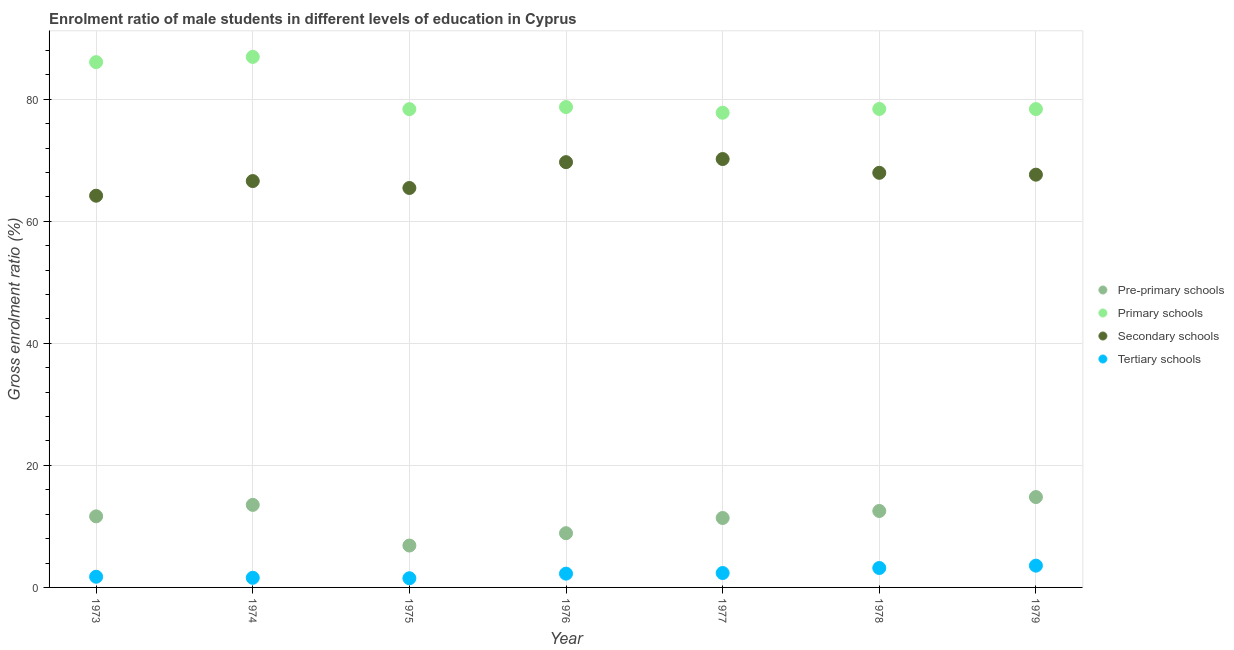Is the number of dotlines equal to the number of legend labels?
Your response must be concise. Yes. What is the gross enrolment ratio(female) in pre-primary schools in 1978?
Offer a very short reply. 12.53. Across all years, what is the maximum gross enrolment ratio(female) in primary schools?
Give a very brief answer. 86.93. Across all years, what is the minimum gross enrolment ratio(female) in primary schools?
Your answer should be very brief. 77.78. In which year was the gross enrolment ratio(female) in pre-primary schools maximum?
Ensure brevity in your answer.  1979. In which year was the gross enrolment ratio(female) in primary schools minimum?
Provide a succinct answer. 1977. What is the total gross enrolment ratio(female) in primary schools in the graph?
Provide a short and direct response. 564.64. What is the difference between the gross enrolment ratio(female) in primary schools in 1976 and that in 1979?
Your answer should be compact. 0.33. What is the difference between the gross enrolment ratio(female) in secondary schools in 1978 and the gross enrolment ratio(female) in pre-primary schools in 1976?
Keep it short and to the point. 59.05. What is the average gross enrolment ratio(female) in pre-primary schools per year?
Offer a terse response. 11.37. In the year 1979, what is the difference between the gross enrolment ratio(female) in tertiary schools and gross enrolment ratio(female) in primary schools?
Your response must be concise. -74.81. In how many years, is the gross enrolment ratio(female) in secondary schools greater than 32 %?
Your answer should be very brief. 7. What is the ratio of the gross enrolment ratio(female) in primary schools in 1976 to that in 1978?
Offer a very short reply. 1. What is the difference between the highest and the second highest gross enrolment ratio(female) in pre-primary schools?
Your answer should be compact. 1.28. What is the difference between the highest and the lowest gross enrolment ratio(female) in tertiary schools?
Your answer should be compact. 2.07. Is it the case that in every year, the sum of the gross enrolment ratio(female) in pre-primary schools and gross enrolment ratio(female) in primary schools is greater than the gross enrolment ratio(female) in secondary schools?
Keep it short and to the point. Yes. How many dotlines are there?
Give a very brief answer. 4. Are the values on the major ticks of Y-axis written in scientific E-notation?
Provide a short and direct response. No. Does the graph contain any zero values?
Your response must be concise. No. How are the legend labels stacked?
Keep it short and to the point. Vertical. What is the title of the graph?
Your response must be concise. Enrolment ratio of male students in different levels of education in Cyprus. Does "Belgium" appear as one of the legend labels in the graph?
Provide a short and direct response. No. What is the Gross enrolment ratio (%) of Pre-primary schools in 1973?
Your response must be concise. 11.64. What is the Gross enrolment ratio (%) of Primary schools in 1973?
Ensure brevity in your answer.  86.07. What is the Gross enrolment ratio (%) in Secondary schools in 1973?
Ensure brevity in your answer.  64.19. What is the Gross enrolment ratio (%) in Tertiary schools in 1973?
Your response must be concise. 1.75. What is the Gross enrolment ratio (%) of Pre-primary schools in 1974?
Provide a short and direct response. 13.52. What is the Gross enrolment ratio (%) in Primary schools in 1974?
Your answer should be very brief. 86.93. What is the Gross enrolment ratio (%) in Secondary schools in 1974?
Your answer should be very brief. 66.58. What is the Gross enrolment ratio (%) in Tertiary schools in 1974?
Give a very brief answer. 1.58. What is the Gross enrolment ratio (%) of Pre-primary schools in 1975?
Your answer should be compact. 6.86. What is the Gross enrolment ratio (%) of Primary schools in 1975?
Your answer should be compact. 78.37. What is the Gross enrolment ratio (%) in Secondary schools in 1975?
Ensure brevity in your answer.  65.45. What is the Gross enrolment ratio (%) of Tertiary schools in 1975?
Make the answer very short. 1.5. What is the Gross enrolment ratio (%) of Pre-primary schools in 1976?
Offer a very short reply. 8.88. What is the Gross enrolment ratio (%) of Primary schools in 1976?
Offer a very short reply. 78.71. What is the Gross enrolment ratio (%) in Secondary schools in 1976?
Provide a short and direct response. 69.68. What is the Gross enrolment ratio (%) in Tertiary schools in 1976?
Offer a very short reply. 2.26. What is the Gross enrolment ratio (%) of Pre-primary schools in 1977?
Keep it short and to the point. 11.38. What is the Gross enrolment ratio (%) of Primary schools in 1977?
Offer a very short reply. 77.78. What is the Gross enrolment ratio (%) in Secondary schools in 1977?
Ensure brevity in your answer.  70.19. What is the Gross enrolment ratio (%) of Tertiary schools in 1977?
Offer a terse response. 2.36. What is the Gross enrolment ratio (%) in Pre-primary schools in 1978?
Your response must be concise. 12.53. What is the Gross enrolment ratio (%) of Primary schools in 1978?
Keep it short and to the point. 78.4. What is the Gross enrolment ratio (%) in Secondary schools in 1978?
Offer a terse response. 67.94. What is the Gross enrolment ratio (%) in Tertiary schools in 1978?
Ensure brevity in your answer.  3.18. What is the Gross enrolment ratio (%) of Pre-primary schools in 1979?
Keep it short and to the point. 14.81. What is the Gross enrolment ratio (%) of Primary schools in 1979?
Provide a succinct answer. 78.38. What is the Gross enrolment ratio (%) of Secondary schools in 1979?
Your answer should be compact. 67.63. What is the Gross enrolment ratio (%) of Tertiary schools in 1979?
Provide a succinct answer. 3.57. Across all years, what is the maximum Gross enrolment ratio (%) in Pre-primary schools?
Provide a short and direct response. 14.81. Across all years, what is the maximum Gross enrolment ratio (%) of Primary schools?
Make the answer very short. 86.93. Across all years, what is the maximum Gross enrolment ratio (%) of Secondary schools?
Offer a very short reply. 70.19. Across all years, what is the maximum Gross enrolment ratio (%) in Tertiary schools?
Provide a succinct answer. 3.57. Across all years, what is the minimum Gross enrolment ratio (%) of Pre-primary schools?
Offer a very short reply. 6.86. Across all years, what is the minimum Gross enrolment ratio (%) in Primary schools?
Offer a terse response. 77.78. Across all years, what is the minimum Gross enrolment ratio (%) in Secondary schools?
Provide a short and direct response. 64.19. Across all years, what is the minimum Gross enrolment ratio (%) of Tertiary schools?
Give a very brief answer. 1.5. What is the total Gross enrolment ratio (%) of Pre-primary schools in the graph?
Offer a very short reply. 79.62. What is the total Gross enrolment ratio (%) of Primary schools in the graph?
Make the answer very short. 564.64. What is the total Gross enrolment ratio (%) in Secondary schools in the graph?
Provide a succinct answer. 471.66. What is the total Gross enrolment ratio (%) of Tertiary schools in the graph?
Keep it short and to the point. 16.2. What is the difference between the Gross enrolment ratio (%) of Pre-primary schools in 1973 and that in 1974?
Keep it short and to the point. -1.88. What is the difference between the Gross enrolment ratio (%) of Primary schools in 1973 and that in 1974?
Offer a terse response. -0.86. What is the difference between the Gross enrolment ratio (%) of Secondary schools in 1973 and that in 1974?
Offer a terse response. -2.4. What is the difference between the Gross enrolment ratio (%) of Tertiary schools in 1973 and that in 1974?
Make the answer very short. 0.17. What is the difference between the Gross enrolment ratio (%) of Pre-primary schools in 1973 and that in 1975?
Ensure brevity in your answer.  4.78. What is the difference between the Gross enrolment ratio (%) of Primary schools in 1973 and that in 1975?
Your response must be concise. 7.7. What is the difference between the Gross enrolment ratio (%) of Secondary schools in 1973 and that in 1975?
Ensure brevity in your answer.  -1.27. What is the difference between the Gross enrolment ratio (%) of Tertiary schools in 1973 and that in 1975?
Keep it short and to the point. 0.25. What is the difference between the Gross enrolment ratio (%) in Pre-primary schools in 1973 and that in 1976?
Offer a terse response. 2.76. What is the difference between the Gross enrolment ratio (%) of Primary schools in 1973 and that in 1976?
Provide a short and direct response. 7.36. What is the difference between the Gross enrolment ratio (%) in Secondary schools in 1973 and that in 1976?
Your answer should be compact. -5.5. What is the difference between the Gross enrolment ratio (%) in Tertiary schools in 1973 and that in 1976?
Ensure brevity in your answer.  -0.51. What is the difference between the Gross enrolment ratio (%) in Pre-primary schools in 1973 and that in 1977?
Offer a very short reply. 0.27. What is the difference between the Gross enrolment ratio (%) in Primary schools in 1973 and that in 1977?
Offer a terse response. 8.29. What is the difference between the Gross enrolment ratio (%) in Secondary schools in 1973 and that in 1977?
Make the answer very short. -6.01. What is the difference between the Gross enrolment ratio (%) in Tertiary schools in 1973 and that in 1977?
Your response must be concise. -0.61. What is the difference between the Gross enrolment ratio (%) in Pre-primary schools in 1973 and that in 1978?
Make the answer very short. -0.88. What is the difference between the Gross enrolment ratio (%) in Primary schools in 1973 and that in 1978?
Your answer should be very brief. 7.67. What is the difference between the Gross enrolment ratio (%) of Secondary schools in 1973 and that in 1978?
Provide a succinct answer. -3.75. What is the difference between the Gross enrolment ratio (%) in Tertiary schools in 1973 and that in 1978?
Your answer should be compact. -1.43. What is the difference between the Gross enrolment ratio (%) in Pre-primary schools in 1973 and that in 1979?
Make the answer very short. -3.16. What is the difference between the Gross enrolment ratio (%) in Primary schools in 1973 and that in 1979?
Ensure brevity in your answer.  7.69. What is the difference between the Gross enrolment ratio (%) in Secondary schools in 1973 and that in 1979?
Provide a short and direct response. -3.45. What is the difference between the Gross enrolment ratio (%) of Tertiary schools in 1973 and that in 1979?
Offer a terse response. -1.82. What is the difference between the Gross enrolment ratio (%) of Pre-primary schools in 1974 and that in 1975?
Make the answer very short. 6.66. What is the difference between the Gross enrolment ratio (%) of Primary schools in 1974 and that in 1975?
Provide a short and direct response. 8.56. What is the difference between the Gross enrolment ratio (%) in Secondary schools in 1974 and that in 1975?
Provide a succinct answer. 1.13. What is the difference between the Gross enrolment ratio (%) in Tertiary schools in 1974 and that in 1975?
Make the answer very short. 0.07. What is the difference between the Gross enrolment ratio (%) in Pre-primary schools in 1974 and that in 1976?
Make the answer very short. 4.64. What is the difference between the Gross enrolment ratio (%) of Primary schools in 1974 and that in 1976?
Provide a succinct answer. 8.22. What is the difference between the Gross enrolment ratio (%) in Secondary schools in 1974 and that in 1976?
Ensure brevity in your answer.  -3.1. What is the difference between the Gross enrolment ratio (%) of Tertiary schools in 1974 and that in 1976?
Provide a succinct answer. -0.68. What is the difference between the Gross enrolment ratio (%) in Pre-primary schools in 1974 and that in 1977?
Offer a terse response. 2.15. What is the difference between the Gross enrolment ratio (%) in Primary schools in 1974 and that in 1977?
Make the answer very short. 9.15. What is the difference between the Gross enrolment ratio (%) of Secondary schools in 1974 and that in 1977?
Offer a terse response. -3.61. What is the difference between the Gross enrolment ratio (%) in Tertiary schools in 1974 and that in 1977?
Keep it short and to the point. -0.78. What is the difference between the Gross enrolment ratio (%) of Pre-primary schools in 1974 and that in 1978?
Ensure brevity in your answer.  1. What is the difference between the Gross enrolment ratio (%) of Primary schools in 1974 and that in 1978?
Make the answer very short. 8.53. What is the difference between the Gross enrolment ratio (%) in Secondary schools in 1974 and that in 1978?
Your answer should be very brief. -1.35. What is the difference between the Gross enrolment ratio (%) of Tertiary schools in 1974 and that in 1978?
Offer a terse response. -1.6. What is the difference between the Gross enrolment ratio (%) of Pre-primary schools in 1974 and that in 1979?
Offer a terse response. -1.28. What is the difference between the Gross enrolment ratio (%) of Primary schools in 1974 and that in 1979?
Make the answer very short. 8.55. What is the difference between the Gross enrolment ratio (%) in Secondary schools in 1974 and that in 1979?
Keep it short and to the point. -1.05. What is the difference between the Gross enrolment ratio (%) of Tertiary schools in 1974 and that in 1979?
Keep it short and to the point. -1.99. What is the difference between the Gross enrolment ratio (%) of Pre-primary schools in 1975 and that in 1976?
Your answer should be compact. -2.02. What is the difference between the Gross enrolment ratio (%) in Primary schools in 1975 and that in 1976?
Offer a very short reply. -0.34. What is the difference between the Gross enrolment ratio (%) of Secondary schools in 1975 and that in 1976?
Offer a terse response. -4.23. What is the difference between the Gross enrolment ratio (%) in Tertiary schools in 1975 and that in 1976?
Offer a terse response. -0.75. What is the difference between the Gross enrolment ratio (%) in Pre-primary schools in 1975 and that in 1977?
Your answer should be compact. -4.51. What is the difference between the Gross enrolment ratio (%) in Primary schools in 1975 and that in 1977?
Your answer should be compact. 0.59. What is the difference between the Gross enrolment ratio (%) in Secondary schools in 1975 and that in 1977?
Provide a short and direct response. -4.74. What is the difference between the Gross enrolment ratio (%) in Tertiary schools in 1975 and that in 1977?
Ensure brevity in your answer.  -0.86. What is the difference between the Gross enrolment ratio (%) in Pre-primary schools in 1975 and that in 1978?
Offer a terse response. -5.66. What is the difference between the Gross enrolment ratio (%) of Primary schools in 1975 and that in 1978?
Give a very brief answer. -0.03. What is the difference between the Gross enrolment ratio (%) in Secondary schools in 1975 and that in 1978?
Ensure brevity in your answer.  -2.48. What is the difference between the Gross enrolment ratio (%) in Tertiary schools in 1975 and that in 1978?
Your answer should be compact. -1.68. What is the difference between the Gross enrolment ratio (%) of Pre-primary schools in 1975 and that in 1979?
Offer a very short reply. -7.94. What is the difference between the Gross enrolment ratio (%) of Primary schools in 1975 and that in 1979?
Provide a succinct answer. -0.01. What is the difference between the Gross enrolment ratio (%) in Secondary schools in 1975 and that in 1979?
Your response must be concise. -2.18. What is the difference between the Gross enrolment ratio (%) in Tertiary schools in 1975 and that in 1979?
Your answer should be compact. -2.07. What is the difference between the Gross enrolment ratio (%) of Pre-primary schools in 1976 and that in 1977?
Make the answer very short. -2.49. What is the difference between the Gross enrolment ratio (%) in Primary schools in 1976 and that in 1977?
Keep it short and to the point. 0.93. What is the difference between the Gross enrolment ratio (%) in Secondary schools in 1976 and that in 1977?
Your answer should be compact. -0.51. What is the difference between the Gross enrolment ratio (%) in Tertiary schools in 1976 and that in 1977?
Provide a succinct answer. -0.1. What is the difference between the Gross enrolment ratio (%) in Pre-primary schools in 1976 and that in 1978?
Make the answer very short. -3.64. What is the difference between the Gross enrolment ratio (%) in Primary schools in 1976 and that in 1978?
Provide a short and direct response. 0.31. What is the difference between the Gross enrolment ratio (%) of Secondary schools in 1976 and that in 1978?
Provide a succinct answer. 1.75. What is the difference between the Gross enrolment ratio (%) of Tertiary schools in 1976 and that in 1978?
Provide a short and direct response. -0.92. What is the difference between the Gross enrolment ratio (%) in Pre-primary schools in 1976 and that in 1979?
Give a very brief answer. -5.92. What is the difference between the Gross enrolment ratio (%) in Primary schools in 1976 and that in 1979?
Keep it short and to the point. 0.33. What is the difference between the Gross enrolment ratio (%) of Secondary schools in 1976 and that in 1979?
Offer a terse response. 2.05. What is the difference between the Gross enrolment ratio (%) of Tertiary schools in 1976 and that in 1979?
Provide a short and direct response. -1.31. What is the difference between the Gross enrolment ratio (%) of Pre-primary schools in 1977 and that in 1978?
Ensure brevity in your answer.  -1.15. What is the difference between the Gross enrolment ratio (%) of Primary schools in 1977 and that in 1978?
Ensure brevity in your answer.  -0.62. What is the difference between the Gross enrolment ratio (%) in Secondary schools in 1977 and that in 1978?
Keep it short and to the point. 2.26. What is the difference between the Gross enrolment ratio (%) of Tertiary schools in 1977 and that in 1978?
Offer a terse response. -0.82. What is the difference between the Gross enrolment ratio (%) of Pre-primary schools in 1977 and that in 1979?
Your answer should be compact. -3.43. What is the difference between the Gross enrolment ratio (%) in Primary schools in 1977 and that in 1979?
Provide a succinct answer. -0.6. What is the difference between the Gross enrolment ratio (%) in Secondary schools in 1977 and that in 1979?
Keep it short and to the point. 2.56. What is the difference between the Gross enrolment ratio (%) in Tertiary schools in 1977 and that in 1979?
Ensure brevity in your answer.  -1.21. What is the difference between the Gross enrolment ratio (%) of Pre-primary schools in 1978 and that in 1979?
Your answer should be very brief. -2.28. What is the difference between the Gross enrolment ratio (%) in Primary schools in 1978 and that in 1979?
Ensure brevity in your answer.  0.02. What is the difference between the Gross enrolment ratio (%) in Secondary schools in 1978 and that in 1979?
Give a very brief answer. 0.3. What is the difference between the Gross enrolment ratio (%) of Tertiary schools in 1978 and that in 1979?
Provide a succinct answer. -0.39. What is the difference between the Gross enrolment ratio (%) of Pre-primary schools in 1973 and the Gross enrolment ratio (%) of Primary schools in 1974?
Keep it short and to the point. -75.29. What is the difference between the Gross enrolment ratio (%) in Pre-primary schools in 1973 and the Gross enrolment ratio (%) in Secondary schools in 1974?
Give a very brief answer. -54.94. What is the difference between the Gross enrolment ratio (%) in Pre-primary schools in 1973 and the Gross enrolment ratio (%) in Tertiary schools in 1974?
Provide a short and direct response. 10.07. What is the difference between the Gross enrolment ratio (%) in Primary schools in 1973 and the Gross enrolment ratio (%) in Secondary schools in 1974?
Give a very brief answer. 19.49. What is the difference between the Gross enrolment ratio (%) in Primary schools in 1973 and the Gross enrolment ratio (%) in Tertiary schools in 1974?
Provide a short and direct response. 84.49. What is the difference between the Gross enrolment ratio (%) in Secondary schools in 1973 and the Gross enrolment ratio (%) in Tertiary schools in 1974?
Offer a very short reply. 62.61. What is the difference between the Gross enrolment ratio (%) in Pre-primary schools in 1973 and the Gross enrolment ratio (%) in Primary schools in 1975?
Keep it short and to the point. -66.72. What is the difference between the Gross enrolment ratio (%) of Pre-primary schools in 1973 and the Gross enrolment ratio (%) of Secondary schools in 1975?
Give a very brief answer. -53.81. What is the difference between the Gross enrolment ratio (%) of Pre-primary schools in 1973 and the Gross enrolment ratio (%) of Tertiary schools in 1975?
Offer a terse response. 10.14. What is the difference between the Gross enrolment ratio (%) in Primary schools in 1973 and the Gross enrolment ratio (%) in Secondary schools in 1975?
Provide a short and direct response. 20.62. What is the difference between the Gross enrolment ratio (%) of Primary schools in 1973 and the Gross enrolment ratio (%) of Tertiary schools in 1975?
Your answer should be compact. 84.57. What is the difference between the Gross enrolment ratio (%) in Secondary schools in 1973 and the Gross enrolment ratio (%) in Tertiary schools in 1975?
Provide a short and direct response. 62.68. What is the difference between the Gross enrolment ratio (%) in Pre-primary schools in 1973 and the Gross enrolment ratio (%) in Primary schools in 1976?
Offer a terse response. -67.07. What is the difference between the Gross enrolment ratio (%) of Pre-primary schools in 1973 and the Gross enrolment ratio (%) of Secondary schools in 1976?
Keep it short and to the point. -58.04. What is the difference between the Gross enrolment ratio (%) in Pre-primary schools in 1973 and the Gross enrolment ratio (%) in Tertiary schools in 1976?
Provide a succinct answer. 9.39. What is the difference between the Gross enrolment ratio (%) of Primary schools in 1973 and the Gross enrolment ratio (%) of Secondary schools in 1976?
Make the answer very short. 16.39. What is the difference between the Gross enrolment ratio (%) in Primary schools in 1973 and the Gross enrolment ratio (%) in Tertiary schools in 1976?
Your answer should be compact. 83.81. What is the difference between the Gross enrolment ratio (%) of Secondary schools in 1973 and the Gross enrolment ratio (%) of Tertiary schools in 1976?
Keep it short and to the point. 61.93. What is the difference between the Gross enrolment ratio (%) of Pre-primary schools in 1973 and the Gross enrolment ratio (%) of Primary schools in 1977?
Your response must be concise. -66.14. What is the difference between the Gross enrolment ratio (%) in Pre-primary schools in 1973 and the Gross enrolment ratio (%) in Secondary schools in 1977?
Give a very brief answer. -58.55. What is the difference between the Gross enrolment ratio (%) of Pre-primary schools in 1973 and the Gross enrolment ratio (%) of Tertiary schools in 1977?
Offer a very short reply. 9.28. What is the difference between the Gross enrolment ratio (%) of Primary schools in 1973 and the Gross enrolment ratio (%) of Secondary schools in 1977?
Provide a succinct answer. 15.88. What is the difference between the Gross enrolment ratio (%) of Primary schools in 1973 and the Gross enrolment ratio (%) of Tertiary schools in 1977?
Ensure brevity in your answer.  83.71. What is the difference between the Gross enrolment ratio (%) in Secondary schools in 1973 and the Gross enrolment ratio (%) in Tertiary schools in 1977?
Your answer should be very brief. 61.82. What is the difference between the Gross enrolment ratio (%) of Pre-primary schools in 1973 and the Gross enrolment ratio (%) of Primary schools in 1978?
Your response must be concise. -66.76. What is the difference between the Gross enrolment ratio (%) of Pre-primary schools in 1973 and the Gross enrolment ratio (%) of Secondary schools in 1978?
Give a very brief answer. -56.29. What is the difference between the Gross enrolment ratio (%) in Pre-primary schools in 1973 and the Gross enrolment ratio (%) in Tertiary schools in 1978?
Your response must be concise. 8.46. What is the difference between the Gross enrolment ratio (%) in Primary schools in 1973 and the Gross enrolment ratio (%) in Secondary schools in 1978?
Your answer should be compact. 18.14. What is the difference between the Gross enrolment ratio (%) in Primary schools in 1973 and the Gross enrolment ratio (%) in Tertiary schools in 1978?
Provide a succinct answer. 82.89. What is the difference between the Gross enrolment ratio (%) of Secondary schools in 1973 and the Gross enrolment ratio (%) of Tertiary schools in 1978?
Your response must be concise. 61. What is the difference between the Gross enrolment ratio (%) of Pre-primary schools in 1973 and the Gross enrolment ratio (%) of Primary schools in 1979?
Provide a succinct answer. -66.74. What is the difference between the Gross enrolment ratio (%) in Pre-primary schools in 1973 and the Gross enrolment ratio (%) in Secondary schools in 1979?
Your answer should be very brief. -55.99. What is the difference between the Gross enrolment ratio (%) of Pre-primary schools in 1973 and the Gross enrolment ratio (%) of Tertiary schools in 1979?
Ensure brevity in your answer.  8.07. What is the difference between the Gross enrolment ratio (%) of Primary schools in 1973 and the Gross enrolment ratio (%) of Secondary schools in 1979?
Your response must be concise. 18.44. What is the difference between the Gross enrolment ratio (%) of Primary schools in 1973 and the Gross enrolment ratio (%) of Tertiary schools in 1979?
Your answer should be very brief. 82.5. What is the difference between the Gross enrolment ratio (%) of Secondary schools in 1973 and the Gross enrolment ratio (%) of Tertiary schools in 1979?
Offer a very short reply. 60.62. What is the difference between the Gross enrolment ratio (%) of Pre-primary schools in 1974 and the Gross enrolment ratio (%) of Primary schools in 1975?
Keep it short and to the point. -64.84. What is the difference between the Gross enrolment ratio (%) of Pre-primary schools in 1974 and the Gross enrolment ratio (%) of Secondary schools in 1975?
Ensure brevity in your answer.  -51.93. What is the difference between the Gross enrolment ratio (%) in Pre-primary schools in 1974 and the Gross enrolment ratio (%) in Tertiary schools in 1975?
Keep it short and to the point. 12.02. What is the difference between the Gross enrolment ratio (%) of Primary schools in 1974 and the Gross enrolment ratio (%) of Secondary schools in 1975?
Your answer should be very brief. 21.48. What is the difference between the Gross enrolment ratio (%) in Primary schools in 1974 and the Gross enrolment ratio (%) in Tertiary schools in 1975?
Keep it short and to the point. 85.43. What is the difference between the Gross enrolment ratio (%) of Secondary schools in 1974 and the Gross enrolment ratio (%) of Tertiary schools in 1975?
Offer a very short reply. 65.08. What is the difference between the Gross enrolment ratio (%) in Pre-primary schools in 1974 and the Gross enrolment ratio (%) in Primary schools in 1976?
Ensure brevity in your answer.  -65.19. What is the difference between the Gross enrolment ratio (%) in Pre-primary schools in 1974 and the Gross enrolment ratio (%) in Secondary schools in 1976?
Keep it short and to the point. -56.16. What is the difference between the Gross enrolment ratio (%) in Pre-primary schools in 1974 and the Gross enrolment ratio (%) in Tertiary schools in 1976?
Your answer should be compact. 11.27. What is the difference between the Gross enrolment ratio (%) of Primary schools in 1974 and the Gross enrolment ratio (%) of Secondary schools in 1976?
Give a very brief answer. 17.25. What is the difference between the Gross enrolment ratio (%) of Primary schools in 1974 and the Gross enrolment ratio (%) of Tertiary schools in 1976?
Give a very brief answer. 84.67. What is the difference between the Gross enrolment ratio (%) in Secondary schools in 1974 and the Gross enrolment ratio (%) in Tertiary schools in 1976?
Your answer should be very brief. 64.33. What is the difference between the Gross enrolment ratio (%) of Pre-primary schools in 1974 and the Gross enrolment ratio (%) of Primary schools in 1977?
Your answer should be compact. -64.26. What is the difference between the Gross enrolment ratio (%) of Pre-primary schools in 1974 and the Gross enrolment ratio (%) of Secondary schools in 1977?
Provide a succinct answer. -56.67. What is the difference between the Gross enrolment ratio (%) of Pre-primary schools in 1974 and the Gross enrolment ratio (%) of Tertiary schools in 1977?
Make the answer very short. 11.16. What is the difference between the Gross enrolment ratio (%) in Primary schools in 1974 and the Gross enrolment ratio (%) in Secondary schools in 1977?
Make the answer very short. 16.74. What is the difference between the Gross enrolment ratio (%) in Primary schools in 1974 and the Gross enrolment ratio (%) in Tertiary schools in 1977?
Make the answer very short. 84.57. What is the difference between the Gross enrolment ratio (%) in Secondary schools in 1974 and the Gross enrolment ratio (%) in Tertiary schools in 1977?
Provide a succinct answer. 64.22. What is the difference between the Gross enrolment ratio (%) in Pre-primary schools in 1974 and the Gross enrolment ratio (%) in Primary schools in 1978?
Your answer should be very brief. -64.88. What is the difference between the Gross enrolment ratio (%) of Pre-primary schools in 1974 and the Gross enrolment ratio (%) of Secondary schools in 1978?
Your response must be concise. -54.41. What is the difference between the Gross enrolment ratio (%) in Pre-primary schools in 1974 and the Gross enrolment ratio (%) in Tertiary schools in 1978?
Give a very brief answer. 10.34. What is the difference between the Gross enrolment ratio (%) of Primary schools in 1974 and the Gross enrolment ratio (%) of Secondary schools in 1978?
Provide a short and direct response. 18.99. What is the difference between the Gross enrolment ratio (%) of Primary schools in 1974 and the Gross enrolment ratio (%) of Tertiary schools in 1978?
Your answer should be compact. 83.75. What is the difference between the Gross enrolment ratio (%) in Secondary schools in 1974 and the Gross enrolment ratio (%) in Tertiary schools in 1978?
Offer a very short reply. 63.4. What is the difference between the Gross enrolment ratio (%) of Pre-primary schools in 1974 and the Gross enrolment ratio (%) of Primary schools in 1979?
Keep it short and to the point. -64.86. What is the difference between the Gross enrolment ratio (%) in Pre-primary schools in 1974 and the Gross enrolment ratio (%) in Secondary schools in 1979?
Your answer should be compact. -54.11. What is the difference between the Gross enrolment ratio (%) of Pre-primary schools in 1974 and the Gross enrolment ratio (%) of Tertiary schools in 1979?
Ensure brevity in your answer.  9.96. What is the difference between the Gross enrolment ratio (%) in Primary schools in 1974 and the Gross enrolment ratio (%) in Secondary schools in 1979?
Give a very brief answer. 19.3. What is the difference between the Gross enrolment ratio (%) of Primary schools in 1974 and the Gross enrolment ratio (%) of Tertiary schools in 1979?
Your response must be concise. 83.36. What is the difference between the Gross enrolment ratio (%) in Secondary schools in 1974 and the Gross enrolment ratio (%) in Tertiary schools in 1979?
Keep it short and to the point. 63.01. What is the difference between the Gross enrolment ratio (%) of Pre-primary schools in 1975 and the Gross enrolment ratio (%) of Primary schools in 1976?
Provide a short and direct response. -71.85. What is the difference between the Gross enrolment ratio (%) in Pre-primary schools in 1975 and the Gross enrolment ratio (%) in Secondary schools in 1976?
Your answer should be compact. -62.82. What is the difference between the Gross enrolment ratio (%) of Pre-primary schools in 1975 and the Gross enrolment ratio (%) of Tertiary schools in 1976?
Your response must be concise. 4.61. What is the difference between the Gross enrolment ratio (%) in Primary schools in 1975 and the Gross enrolment ratio (%) in Secondary schools in 1976?
Ensure brevity in your answer.  8.69. What is the difference between the Gross enrolment ratio (%) in Primary schools in 1975 and the Gross enrolment ratio (%) in Tertiary schools in 1976?
Your response must be concise. 76.11. What is the difference between the Gross enrolment ratio (%) in Secondary schools in 1975 and the Gross enrolment ratio (%) in Tertiary schools in 1976?
Provide a succinct answer. 63.19. What is the difference between the Gross enrolment ratio (%) in Pre-primary schools in 1975 and the Gross enrolment ratio (%) in Primary schools in 1977?
Offer a very short reply. -70.92. What is the difference between the Gross enrolment ratio (%) of Pre-primary schools in 1975 and the Gross enrolment ratio (%) of Secondary schools in 1977?
Give a very brief answer. -63.33. What is the difference between the Gross enrolment ratio (%) of Pre-primary schools in 1975 and the Gross enrolment ratio (%) of Tertiary schools in 1977?
Provide a short and direct response. 4.5. What is the difference between the Gross enrolment ratio (%) in Primary schools in 1975 and the Gross enrolment ratio (%) in Secondary schools in 1977?
Give a very brief answer. 8.17. What is the difference between the Gross enrolment ratio (%) of Primary schools in 1975 and the Gross enrolment ratio (%) of Tertiary schools in 1977?
Provide a short and direct response. 76.01. What is the difference between the Gross enrolment ratio (%) in Secondary schools in 1975 and the Gross enrolment ratio (%) in Tertiary schools in 1977?
Offer a terse response. 63.09. What is the difference between the Gross enrolment ratio (%) in Pre-primary schools in 1975 and the Gross enrolment ratio (%) in Primary schools in 1978?
Keep it short and to the point. -71.54. What is the difference between the Gross enrolment ratio (%) of Pre-primary schools in 1975 and the Gross enrolment ratio (%) of Secondary schools in 1978?
Make the answer very short. -61.07. What is the difference between the Gross enrolment ratio (%) in Pre-primary schools in 1975 and the Gross enrolment ratio (%) in Tertiary schools in 1978?
Your response must be concise. 3.68. What is the difference between the Gross enrolment ratio (%) of Primary schools in 1975 and the Gross enrolment ratio (%) of Secondary schools in 1978?
Provide a short and direct response. 10.43. What is the difference between the Gross enrolment ratio (%) of Primary schools in 1975 and the Gross enrolment ratio (%) of Tertiary schools in 1978?
Your response must be concise. 75.19. What is the difference between the Gross enrolment ratio (%) in Secondary schools in 1975 and the Gross enrolment ratio (%) in Tertiary schools in 1978?
Keep it short and to the point. 62.27. What is the difference between the Gross enrolment ratio (%) in Pre-primary schools in 1975 and the Gross enrolment ratio (%) in Primary schools in 1979?
Your response must be concise. -71.52. What is the difference between the Gross enrolment ratio (%) of Pre-primary schools in 1975 and the Gross enrolment ratio (%) of Secondary schools in 1979?
Your answer should be very brief. -60.77. What is the difference between the Gross enrolment ratio (%) of Pre-primary schools in 1975 and the Gross enrolment ratio (%) of Tertiary schools in 1979?
Ensure brevity in your answer.  3.29. What is the difference between the Gross enrolment ratio (%) in Primary schools in 1975 and the Gross enrolment ratio (%) in Secondary schools in 1979?
Provide a short and direct response. 10.74. What is the difference between the Gross enrolment ratio (%) in Primary schools in 1975 and the Gross enrolment ratio (%) in Tertiary schools in 1979?
Your answer should be very brief. 74.8. What is the difference between the Gross enrolment ratio (%) in Secondary schools in 1975 and the Gross enrolment ratio (%) in Tertiary schools in 1979?
Offer a very short reply. 61.88. What is the difference between the Gross enrolment ratio (%) of Pre-primary schools in 1976 and the Gross enrolment ratio (%) of Primary schools in 1977?
Ensure brevity in your answer.  -68.9. What is the difference between the Gross enrolment ratio (%) of Pre-primary schools in 1976 and the Gross enrolment ratio (%) of Secondary schools in 1977?
Your answer should be very brief. -61.31. What is the difference between the Gross enrolment ratio (%) in Pre-primary schools in 1976 and the Gross enrolment ratio (%) in Tertiary schools in 1977?
Provide a short and direct response. 6.52. What is the difference between the Gross enrolment ratio (%) in Primary schools in 1976 and the Gross enrolment ratio (%) in Secondary schools in 1977?
Provide a succinct answer. 8.52. What is the difference between the Gross enrolment ratio (%) of Primary schools in 1976 and the Gross enrolment ratio (%) of Tertiary schools in 1977?
Your answer should be very brief. 76.35. What is the difference between the Gross enrolment ratio (%) of Secondary schools in 1976 and the Gross enrolment ratio (%) of Tertiary schools in 1977?
Keep it short and to the point. 67.32. What is the difference between the Gross enrolment ratio (%) of Pre-primary schools in 1976 and the Gross enrolment ratio (%) of Primary schools in 1978?
Give a very brief answer. -69.52. What is the difference between the Gross enrolment ratio (%) in Pre-primary schools in 1976 and the Gross enrolment ratio (%) in Secondary schools in 1978?
Offer a terse response. -59.05. What is the difference between the Gross enrolment ratio (%) in Pre-primary schools in 1976 and the Gross enrolment ratio (%) in Tertiary schools in 1978?
Your answer should be very brief. 5.7. What is the difference between the Gross enrolment ratio (%) of Primary schools in 1976 and the Gross enrolment ratio (%) of Secondary schools in 1978?
Your answer should be very brief. 10.78. What is the difference between the Gross enrolment ratio (%) of Primary schools in 1976 and the Gross enrolment ratio (%) of Tertiary schools in 1978?
Keep it short and to the point. 75.53. What is the difference between the Gross enrolment ratio (%) in Secondary schools in 1976 and the Gross enrolment ratio (%) in Tertiary schools in 1978?
Offer a very short reply. 66.5. What is the difference between the Gross enrolment ratio (%) in Pre-primary schools in 1976 and the Gross enrolment ratio (%) in Primary schools in 1979?
Your response must be concise. -69.5. What is the difference between the Gross enrolment ratio (%) in Pre-primary schools in 1976 and the Gross enrolment ratio (%) in Secondary schools in 1979?
Keep it short and to the point. -58.75. What is the difference between the Gross enrolment ratio (%) in Pre-primary schools in 1976 and the Gross enrolment ratio (%) in Tertiary schools in 1979?
Provide a short and direct response. 5.31. What is the difference between the Gross enrolment ratio (%) in Primary schools in 1976 and the Gross enrolment ratio (%) in Secondary schools in 1979?
Your response must be concise. 11.08. What is the difference between the Gross enrolment ratio (%) of Primary schools in 1976 and the Gross enrolment ratio (%) of Tertiary schools in 1979?
Offer a very short reply. 75.14. What is the difference between the Gross enrolment ratio (%) of Secondary schools in 1976 and the Gross enrolment ratio (%) of Tertiary schools in 1979?
Give a very brief answer. 66.11. What is the difference between the Gross enrolment ratio (%) in Pre-primary schools in 1977 and the Gross enrolment ratio (%) in Primary schools in 1978?
Your answer should be very brief. -67.02. What is the difference between the Gross enrolment ratio (%) in Pre-primary schools in 1977 and the Gross enrolment ratio (%) in Secondary schools in 1978?
Offer a terse response. -56.56. What is the difference between the Gross enrolment ratio (%) of Pre-primary schools in 1977 and the Gross enrolment ratio (%) of Tertiary schools in 1978?
Your response must be concise. 8.19. What is the difference between the Gross enrolment ratio (%) in Primary schools in 1977 and the Gross enrolment ratio (%) in Secondary schools in 1978?
Your answer should be compact. 9.85. What is the difference between the Gross enrolment ratio (%) in Primary schools in 1977 and the Gross enrolment ratio (%) in Tertiary schools in 1978?
Ensure brevity in your answer.  74.6. What is the difference between the Gross enrolment ratio (%) in Secondary schools in 1977 and the Gross enrolment ratio (%) in Tertiary schools in 1978?
Your answer should be compact. 67.01. What is the difference between the Gross enrolment ratio (%) in Pre-primary schools in 1977 and the Gross enrolment ratio (%) in Primary schools in 1979?
Offer a very short reply. -67. What is the difference between the Gross enrolment ratio (%) in Pre-primary schools in 1977 and the Gross enrolment ratio (%) in Secondary schools in 1979?
Your answer should be compact. -56.26. What is the difference between the Gross enrolment ratio (%) in Pre-primary schools in 1977 and the Gross enrolment ratio (%) in Tertiary schools in 1979?
Provide a succinct answer. 7.81. What is the difference between the Gross enrolment ratio (%) in Primary schools in 1977 and the Gross enrolment ratio (%) in Secondary schools in 1979?
Ensure brevity in your answer.  10.15. What is the difference between the Gross enrolment ratio (%) in Primary schools in 1977 and the Gross enrolment ratio (%) in Tertiary schools in 1979?
Your response must be concise. 74.21. What is the difference between the Gross enrolment ratio (%) of Secondary schools in 1977 and the Gross enrolment ratio (%) of Tertiary schools in 1979?
Ensure brevity in your answer.  66.62. What is the difference between the Gross enrolment ratio (%) in Pre-primary schools in 1978 and the Gross enrolment ratio (%) in Primary schools in 1979?
Give a very brief answer. -65.86. What is the difference between the Gross enrolment ratio (%) of Pre-primary schools in 1978 and the Gross enrolment ratio (%) of Secondary schools in 1979?
Offer a very short reply. -55.11. What is the difference between the Gross enrolment ratio (%) of Pre-primary schools in 1978 and the Gross enrolment ratio (%) of Tertiary schools in 1979?
Your response must be concise. 8.96. What is the difference between the Gross enrolment ratio (%) in Primary schools in 1978 and the Gross enrolment ratio (%) in Secondary schools in 1979?
Provide a succinct answer. 10.77. What is the difference between the Gross enrolment ratio (%) in Primary schools in 1978 and the Gross enrolment ratio (%) in Tertiary schools in 1979?
Provide a succinct answer. 74.83. What is the difference between the Gross enrolment ratio (%) of Secondary schools in 1978 and the Gross enrolment ratio (%) of Tertiary schools in 1979?
Keep it short and to the point. 64.37. What is the average Gross enrolment ratio (%) in Pre-primary schools per year?
Your answer should be very brief. 11.37. What is the average Gross enrolment ratio (%) of Primary schools per year?
Ensure brevity in your answer.  80.66. What is the average Gross enrolment ratio (%) in Secondary schools per year?
Offer a very short reply. 67.38. What is the average Gross enrolment ratio (%) in Tertiary schools per year?
Your answer should be very brief. 2.31. In the year 1973, what is the difference between the Gross enrolment ratio (%) in Pre-primary schools and Gross enrolment ratio (%) in Primary schools?
Give a very brief answer. -74.43. In the year 1973, what is the difference between the Gross enrolment ratio (%) in Pre-primary schools and Gross enrolment ratio (%) in Secondary schools?
Your answer should be very brief. -52.54. In the year 1973, what is the difference between the Gross enrolment ratio (%) in Pre-primary schools and Gross enrolment ratio (%) in Tertiary schools?
Your answer should be compact. 9.89. In the year 1973, what is the difference between the Gross enrolment ratio (%) of Primary schools and Gross enrolment ratio (%) of Secondary schools?
Provide a short and direct response. 21.89. In the year 1973, what is the difference between the Gross enrolment ratio (%) of Primary schools and Gross enrolment ratio (%) of Tertiary schools?
Keep it short and to the point. 84.32. In the year 1973, what is the difference between the Gross enrolment ratio (%) in Secondary schools and Gross enrolment ratio (%) in Tertiary schools?
Ensure brevity in your answer.  62.43. In the year 1974, what is the difference between the Gross enrolment ratio (%) of Pre-primary schools and Gross enrolment ratio (%) of Primary schools?
Give a very brief answer. -73.41. In the year 1974, what is the difference between the Gross enrolment ratio (%) in Pre-primary schools and Gross enrolment ratio (%) in Secondary schools?
Give a very brief answer. -53.06. In the year 1974, what is the difference between the Gross enrolment ratio (%) of Pre-primary schools and Gross enrolment ratio (%) of Tertiary schools?
Your answer should be very brief. 11.95. In the year 1974, what is the difference between the Gross enrolment ratio (%) in Primary schools and Gross enrolment ratio (%) in Secondary schools?
Your response must be concise. 20.35. In the year 1974, what is the difference between the Gross enrolment ratio (%) in Primary schools and Gross enrolment ratio (%) in Tertiary schools?
Offer a very short reply. 85.35. In the year 1974, what is the difference between the Gross enrolment ratio (%) of Secondary schools and Gross enrolment ratio (%) of Tertiary schools?
Ensure brevity in your answer.  65.01. In the year 1975, what is the difference between the Gross enrolment ratio (%) of Pre-primary schools and Gross enrolment ratio (%) of Primary schools?
Make the answer very short. -71.5. In the year 1975, what is the difference between the Gross enrolment ratio (%) in Pre-primary schools and Gross enrolment ratio (%) in Secondary schools?
Provide a short and direct response. -58.59. In the year 1975, what is the difference between the Gross enrolment ratio (%) in Pre-primary schools and Gross enrolment ratio (%) in Tertiary schools?
Your answer should be compact. 5.36. In the year 1975, what is the difference between the Gross enrolment ratio (%) in Primary schools and Gross enrolment ratio (%) in Secondary schools?
Give a very brief answer. 12.92. In the year 1975, what is the difference between the Gross enrolment ratio (%) of Primary schools and Gross enrolment ratio (%) of Tertiary schools?
Offer a very short reply. 76.86. In the year 1975, what is the difference between the Gross enrolment ratio (%) in Secondary schools and Gross enrolment ratio (%) in Tertiary schools?
Keep it short and to the point. 63.95. In the year 1976, what is the difference between the Gross enrolment ratio (%) in Pre-primary schools and Gross enrolment ratio (%) in Primary schools?
Provide a succinct answer. -69.83. In the year 1976, what is the difference between the Gross enrolment ratio (%) of Pre-primary schools and Gross enrolment ratio (%) of Secondary schools?
Keep it short and to the point. -60.8. In the year 1976, what is the difference between the Gross enrolment ratio (%) of Pre-primary schools and Gross enrolment ratio (%) of Tertiary schools?
Provide a short and direct response. 6.62. In the year 1976, what is the difference between the Gross enrolment ratio (%) of Primary schools and Gross enrolment ratio (%) of Secondary schools?
Keep it short and to the point. 9.03. In the year 1976, what is the difference between the Gross enrolment ratio (%) of Primary schools and Gross enrolment ratio (%) of Tertiary schools?
Give a very brief answer. 76.45. In the year 1976, what is the difference between the Gross enrolment ratio (%) in Secondary schools and Gross enrolment ratio (%) in Tertiary schools?
Your response must be concise. 67.42. In the year 1977, what is the difference between the Gross enrolment ratio (%) of Pre-primary schools and Gross enrolment ratio (%) of Primary schools?
Keep it short and to the point. -66.4. In the year 1977, what is the difference between the Gross enrolment ratio (%) in Pre-primary schools and Gross enrolment ratio (%) in Secondary schools?
Ensure brevity in your answer.  -58.82. In the year 1977, what is the difference between the Gross enrolment ratio (%) in Pre-primary schools and Gross enrolment ratio (%) in Tertiary schools?
Make the answer very short. 9.02. In the year 1977, what is the difference between the Gross enrolment ratio (%) in Primary schools and Gross enrolment ratio (%) in Secondary schools?
Offer a very short reply. 7.59. In the year 1977, what is the difference between the Gross enrolment ratio (%) of Primary schools and Gross enrolment ratio (%) of Tertiary schools?
Your response must be concise. 75.42. In the year 1977, what is the difference between the Gross enrolment ratio (%) of Secondary schools and Gross enrolment ratio (%) of Tertiary schools?
Your answer should be very brief. 67.83. In the year 1978, what is the difference between the Gross enrolment ratio (%) in Pre-primary schools and Gross enrolment ratio (%) in Primary schools?
Provide a succinct answer. -65.87. In the year 1978, what is the difference between the Gross enrolment ratio (%) in Pre-primary schools and Gross enrolment ratio (%) in Secondary schools?
Your answer should be compact. -55.41. In the year 1978, what is the difference between the Gross enrolment ratio (%) in Pre-primary schools and Gross enrolment ratio (%) in Tertiary schools?
Ensure brevity in your answer.  9.34. In the year 1978, what is the difference between the Gross enrolment ratio (%) in Primary schools and Gross enrolment ratio (%) in Secondary schools?
Provide a succinct answer. 10.46. In the year 1978, what is the difference between the Gross enrolment ratio (%) of Primary schools and Gross enrolment ratio (%) of Tertiary schools?
Your response must be concise. 75.22. In the year 1978, what is the difference between the Gross enrolment ratio (%) in Secondary schools and Gross enrolment ratio (%) in Tertiary schools?
Make the answer very short. 64.75. In the year 1979, what is the difference between the Gross enrolment ratio (%) in Pre-primary schools and Gross enrolment ratio (%) in Primary schools?
Your response must be concise. -63.57. In the year 1979, what is the difference between the Gross enrolment ratio (%) of Pre-primary schools and Gross enrolment ratio (%) of Secondary schools?
Offer a terse response. -52.83. In the year 1979, what is the difference between the Gross enrolment ratio (%) in Pre-primary schools and Gross enrolment ratio (%) in Tertiary schools?
Ensure brevity in your answer.  11.24. In the year 1979, what is the difference between the Gross enrolment ratio (%) of Primary schools and Gross enrolment ratio (%) of Secondary schools?
Make the answer very short. 10.75. In the year 1979, what is the difference between the Gross enrolment ratio (%) of Primary schools and Gross enrolment ratio (%) of Tertiary schools?
Provide a succinct answer. 74.81. In the year 1979, what is the difference between the Gross enrolment ratio (%) in Secondary schools and Gross enrolment ratio (%) in Tertiary schools?
Ensure brevity in your answer.  64.06. What is the ratio of the Gross enrolment ratio (%) of Pre-primary schools in 1973 to that in 1974?
Offer a very short reply. 0.86. What is the ratio of the Gross enrolment ratio (%) of Primary schools in 1973 to that in 1974?
Provide a succinct answer. 0.99. What is the ratio of the Gross enrolment ratio (%) in Secondary schools in 1973 to that in 1974?
Offer a very short reply. 0.96. What is the ratio of the Gross enrolment ratio (%) in Tertiary schools in 1973 to that in 1974?
Give a very brief answer. 1.11. What is the ratio of the Gross enrolment ratio (%) in Pre-primary schools in 1973 to that in 1975?
Your answer should be very brief. 1.7. What is the ratio of the Gross enrolment ratio (%) of Primary schools in 1973 to that in 1975?
Your answer should be very brief. 1.1. What is the ratio of the Gross enrolment ratio (%) in Secondary schools in 1973 to that in 1975?
Provide a succinct answer. 0.98. What is the ratio of the Gross enrolment ratio (%) in Tertiary schools in 1973 to that in 1975?
Offer a very short reply. 1.16. What is the ratio of the Gross enrolment ratio (%) of Pre-primary schools in 1973 to that in 1976?
Give a very brief answer. 1.31. What is the ratio of the Gross enrolment ratio (%) of Primary schools in 1973 to that in 1976?
Your answer should be compact. 1.09. What is the ratio of the Gross enrolment ratio (%) of Secondary schools in 1973 to that in 1976?
Provide a succinct answer. 0.92. What is the ratio of the Gross enrolment ratio (%) in Tertiary schools in 1973 to that in 1976?
Provide a short and direct response. 0.78. What is the ratio of the Gross enrolment ratio (%) of Pre-primary schools in 1973 to that in 1977?
Offer a terse response. 1.02. What is the ratio of the Gross enrolment ratio (%) in Primary schools in 1973 to that in 1977?
Offer a terse response. 1.11. What is the ratio of the Gross enrolment ratio (%) in Secondary schools in 1973 to that in 1977?
Your answer should be very brief. 0.91. What is the ratio of the Gross enrolment ratio (%) of Tertiary schools in 1973 to that in 1977?
Give a very brief answer. 0.74. What is the ratio of the Gross enrolment ratio (%) of Pre-primary schools in 1973 to that in 1978?
Offer a terse response. 0.93. What is the ratio of the Gross enrolment ratio (%) of Primary schools in 1973 to that in 1978?
Offer a terse response. 1.1. What is the ratio of the Gross enrolment ratio (%) of Secondary schools in 1973 to that in 1978?
Your answer should be very brief. 0.94. What is the ratio of the Gross enrolment ratio (%) of Tertiary schools in 1973 to that in 1978?
Keep it short and to the point. 0.55. What is the ratio of the Gross enrolment ratio (%) of Pre-primary schools in 1973 to that in 1979?
Provide a succinct answer. 0.79. What is the ratio of the Gross enrolment ratio (%) in Primary schools in 1973 to that in 1979?
Provide a short and direct response. 1.1. What is the ratio of the Gross enrolment ratio (%) of Secondary schools in 1973 to that in 1979?
Offer a very short reply. 0.95. What is the ratio of the Gross enrolment ratio (%) in Tertiary schools in 1973 to that in 1979?
Make the answer very short. 0.49. What is the ratio of the Gross enrolment ratio (%) of Pre-primary schools in 1974 to that in 1975?
Provide a succinct answer. 1.97. What is the ratio of the Gross enrolment ratio (%) of Primary schools in 1974 to that in 1975?
Ensure brevity in your answer.  1.11. What is the ratio of the Gross enrolment ratio (%) in Secondary schools in 1974 to that in 1975?
Give a very brief answer. 1.02. What is the ratio of the Gross enrolment ratio (%) of Tertiary schools in 1974 to that in 1975?
Your response must be concise. 1.05. What is the ratio of the Gross enrolment ratio (%) of Pre-primary schools in 1974 to that in 1976?
Your answer should be compact. 1.52. What is the ratio of the Gross enrolment ratio (%) of Primary schools in 1974 to that in 1976?
Your answer should be compact. 1.1. What is the ratio of the Gross enrolment ratio (%) in Secondary schools in 1974 to that in 1976?
Provide a succinct answer. 0.96. What is the ratio of the Gross enrolment ratio (%) in Tertiary schools in 1974 to that in 1976?
Provide a short and direct response. 0.7. What is the ratio of the Gross enrolment ratio (%) in Pre-primary schools in 1974 to that in 1977?
Your answer should be compact. 1.19. What is the ratio of the Gross enrolment ratio (%) in Primary schools in 1974 to that in 1977?
Make the answer very short. 1.12. What is the ratio of the Gross enrolment ratio (%) of Secondary schools in 1974 to that in 1977?
Provide a short and direct response. 0.95. What is the ratio of the Gross enrolment ratio (%) in Tertiary schools in 1974 to that in 1977?
Your answer should be compact. 0.67. What is the ratio of the Gross enrolment ratio (%) of Pre-primary schools in 1974 to that in 1978?
Your answer should be compact. 1.08. What is the ratio of the Gross enrolment ratio (%) in Primary schools in 1974 to that in 1978?
Offer a terse response. 1.11. What is the ratio of the Gross enrolment ratio (%) in Secondary schools in 1974 to that in 1978?
Make the answer very short. 0.98. What is the ratio of the Gross enrolment ratio (%) of Tertiary schools in 1974 to that in 1978?
Provide a succinct answer. 0.5. What is the ratio of the Gross enrolment ratio (%) of Pre-primary schools in 1974 to that in 1979?
Make the answer very short. 0.91. What is the ratio of the Gross enrolment ratio (%) of Primary schools in 1974 to that in 1979?
Make the answer very short. 1.11. What is the ratio of the Gross enrolment ratio (%) of Secondary schools in 1974 to that in 1979?
Offer a very short reply. 0.98. What is the ratio of the Gross enrolment ratio (%) in Tertiary schools in 1974 to that in 1979?
Make the answer very short. 0.44. What is the ratio of the Gross enrolment ratio (%) of Pre-primary schools in 1975 to that in 1976?
Offer a terse response. 0.77. What is the ratio of the Gross enrolment ratio (%) in Primary schools in 1975 to that in 1976?
Keep it short and to the point. 1. What is the ratio of the Gross enrolment ratio (%) of Secondary schools in 1975 to that in 1976?
Your answer should be compact. 0.94. What is the ratio of the Gross enrolment ratio (%) of Tertiary schools in 1975 to that in 1976?
Your answer should be compact. 0.67. What is the ratio of the Gross enrolment ratio (%) in Pre-primary schools in 1975 to that in 1977?
Your answer should be compact. 0.6. What is the ratio of the Gross enrolment ratio (%) of Primary schools in 1975 to that in 1977?
Offer a terse response. 1.01. What is the ratio of the Gross enrolment ratio (%) in Secondary schools in 1975 to that in 1977?
Keep it short and to the point. 0.93. What is the ratio of the Gross enrolment ratio (%) of Tertiary schools in 1975 to that in 1977?
Provide a short and direct response. 0.64. What is the ratio of the Gross enrolment ratio (%) of Pre-primary schools in 1975 to that in 1978?
Provide a short and direct response. 0.55. What is the ratio of the Gross enrolment ratio (%) of Primary schools in 1975 to that in 1978?
Offer a very short reply. 1. What is the ratio of the Gross enrolment ratio (%) of Secondary schools in 1975 to that in 1978?
Your response must be concise. 0.96. What is the ratio of the Gross enrolment ratio (%) of Tertiary schools in 1975 to that in 1978?
Make the answer very short. 0.47. What is the ratio of the Gross enrolment ratio (%) in Pre-primary schools in 1975 to that in 1979?
Give a very brief answer. 0.46. What is the ratio of the Gross enrolment ratio (%) in Secondary schools in 1975 to that in 1979?
Your answer should be very brief. 0.97. What is the ratio of the Gross enrolment ratio (%) of Tertiary schools in 1975 to that in 1979?
Your answer should be very brief. 0.42. What is the ratio of the Gross enrolment ratio (%) of Pre-primary schools in 1976 to that in 1977?
Provide a short and direct response. 0.78. What is the ratio of the Gross enrolment ratio (%) in Primary schools in 1976 to that in 1977?
Your answer should be very brief. 1.01. What is the ratio of the Gross enrolment ratio (%) in Secondary schools in 1976 to that in 1977?
Provide a short and direct response. 0.99. What is the ratio of the Gross enrolment ratio (%) of Tertiary schools in 1976 to that in 1977?
Give a very brief answer. 0.96. What is the ratio of the Gross enrolment ratio (%) in Pre-primary schools in 1976 to that in 1978?
Offer a very short reply. 0.71. What is the ratio of the Gross enrolment ratio (%) in Primary schools in 1976 to that in 1978?
Your response must be concise. 1. What is the ratio of the Gross enrolment ratio (%) in Secondary schools in 1976 to that in 1978?
Your answer should be very brief. 1.03. What is the ratio of the Gross enrolment ratio (%) in Tertiary schools in 1976 to that in 1978?
Give a very brief answer. 0.71. What is the ratio of the Gross enrolment ratio (%) of Pre-primary schools in 1976 to that in 1979?
Your answer should be compact. 0.6. What is the ratio of the Gross enrolment ratio (%) of Secondary schools in 1976 to that in 1979?
Ensure brevity in your answer.  1.03. What is the ratio of the Gross enrolment ratio (%) of Tertiary schools in 1976 to that in 1979?
Give a very brief answer. 0.63. What is the ratio of the Gross enrolment ratio (%) in Pre-primary schools in 1977 to that in 1978?
Your answer should be very brief. 0.91. What is the ratio of the Gross enrolment ratio (%) of Primary schools in 1977 to that in 1978?
Ensure brevity in your answer.  0.99. What is the ratio of the Gross enrolment ratio (%) in Secondary schools in 1977 to that in 1978?
Provide a succinct answer. 1.03. What is the ratio of the Gross enrolment ratio (%) in Tertiary schools in 1977 to that in 1978?
Give a very brief answer. 0.74. What is the ratio of the Gross enrolment ratio (%) of Pre-primary schools in 1977 to that in 1979?
Your response must be concise. 0.77. What is the ratio of the Gross enrolment ratio (%) in Primary schools in 1977 to that in 1979?
Provide a short and direct response. 0.99. What is the ratio of the Gross enrolment ratio (%) of Secondary schools in 1977 to that in 1979?
Ensure brevity in your answer.  1.04. What is the ratio of the Gross enrolment ratio (%) in Tertiary schools in 1977 to that in 1979?
Ensure brevity in your answer.  0.66. What is the ratio of the Gross enrolment ratio (%) of Pre-primary schools in 1978 to that in 1979?
Give a very brief answer. 0.85. What is the ratio of the Gross enrolment ratio (%) in Secondary schools in 1978 to that in 1979?
Make the answer very short. 1. What is the ratio of the Gross enrolment ratio (%) in Tertiary schools in 1978 to that in 1979?
Your response must be concise. 0.89. What is the difference between the highest and the second highest Gross enrolment ratio (%) of Pre-primary schools?
Make the answer very short. 1.28. What is the difference between the highest and the second highest Gross enrolment ratio (%) of Primary schools?
Your answer should be very brief. 0.86. What is the difference between the highest and the second highest Gross enrolment ratio (%) of Secondary schools?
Provide a succinct answer. 0.51. What is the difference between the highest and the second highest Gross enrolment ratio (%) in Tertiary schools?
Give a very brief answer. 0.39. What is the difference between the highest and the lowest Gross enrolment ratio (%) in Pre-primary schools?
Ensure brevity in your answer.  7.94. What is the difference between the highest and the lowest Gross enrolment ratio (%) of Primary schools?
Ensure brevity in your answer.  9.15. What is the difference between the highest and the lowest Gross enrolment ratio (%) of Secondary schools?
Your answer should be compact. 6.01. What is the difference between the highest and the lowest Gross enrolment ratio (%) of Tertiary schools?
Provide a short and direct response. 2.07. 